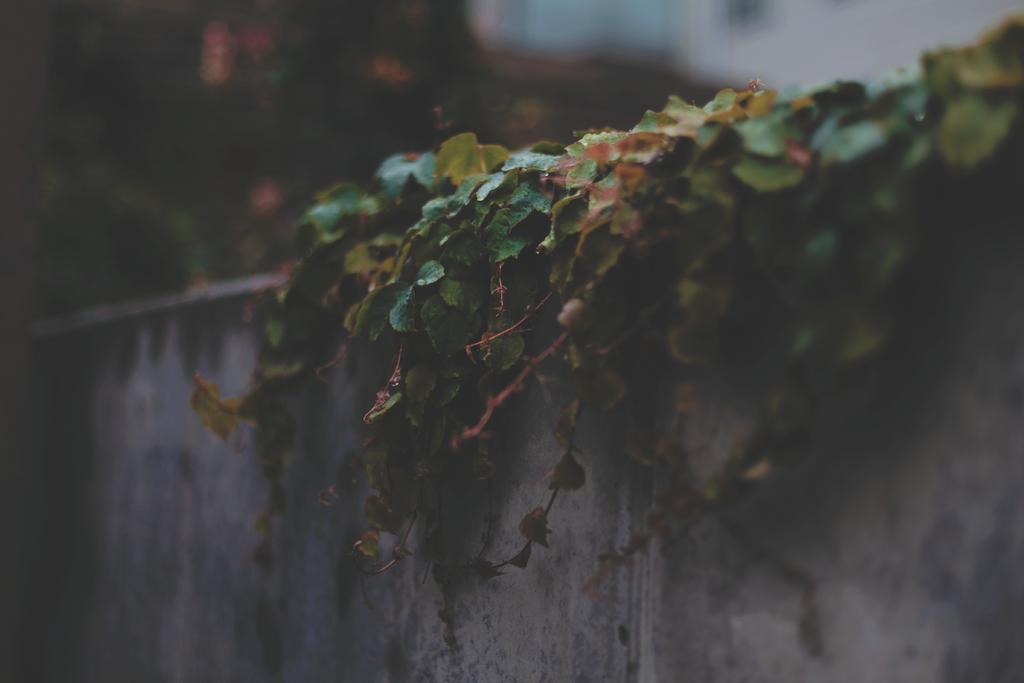In one or two sentences, can you explain what this image depicts? In this image w can see creeper plants on the wall and a blurry background. 